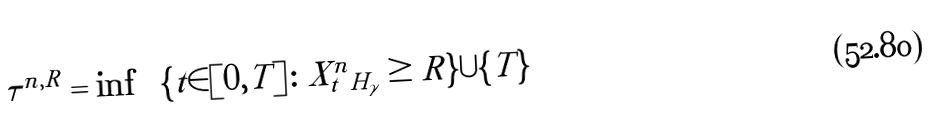<formula> <loc_0><loc_0><loc_500><loc_500>\tau ^ { n , R } = \inf \, \left ( \{ t \in [ 0 , T ] \colon \| X _ { t } ^ { n } \| _ { H _ { \gamma } } \geq R \} \cup \{ T \} \right )</formula> 